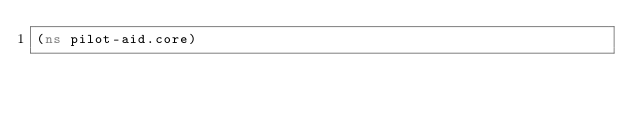Convert code to text. <code><loc_0><loc_0><loc_500><loc_500><_Clojure_>(ns pilot-aid.core)
</code> 